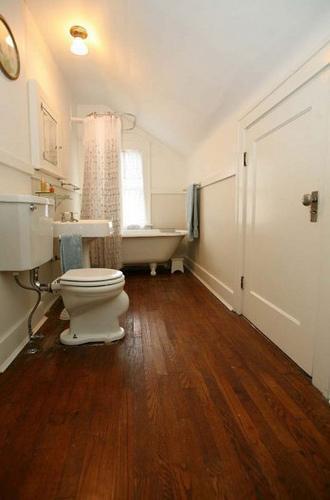How many towels are there hanging in the bathroom?
Give a very brief answer. 2. 